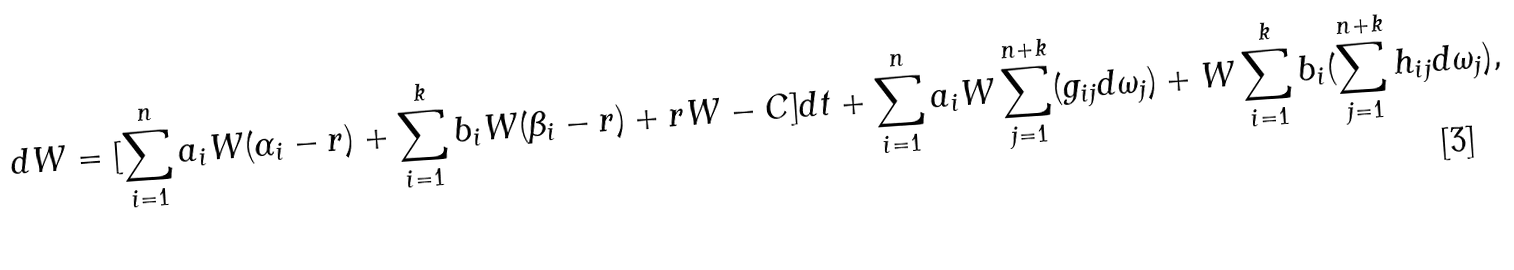Convert formula to latex. <formula><loc_0><loc_0><loc_500><loc_500>d W = [ \sum _ { i = 1 } ^ { n } a _ { i } W ( \alpha _ { i } - r ) + \sum _ { i = 1 } ^ { k } b _ { i } W ( \beta _ { i } - r ) + r W - C ] d t + \sum _ { i = 1 } ^ { n } a _ { i } W \sum _ { j = 1 } ^ { n + k } ( g _ { i j } d \omega _ { j } ) + W \sum _ { i = 1 } ^ { k } b _ { i } ( \sum _ { j = 1 } ^ { n + k } h _ { i j } d \omega _ { j } ) ,</formula> 